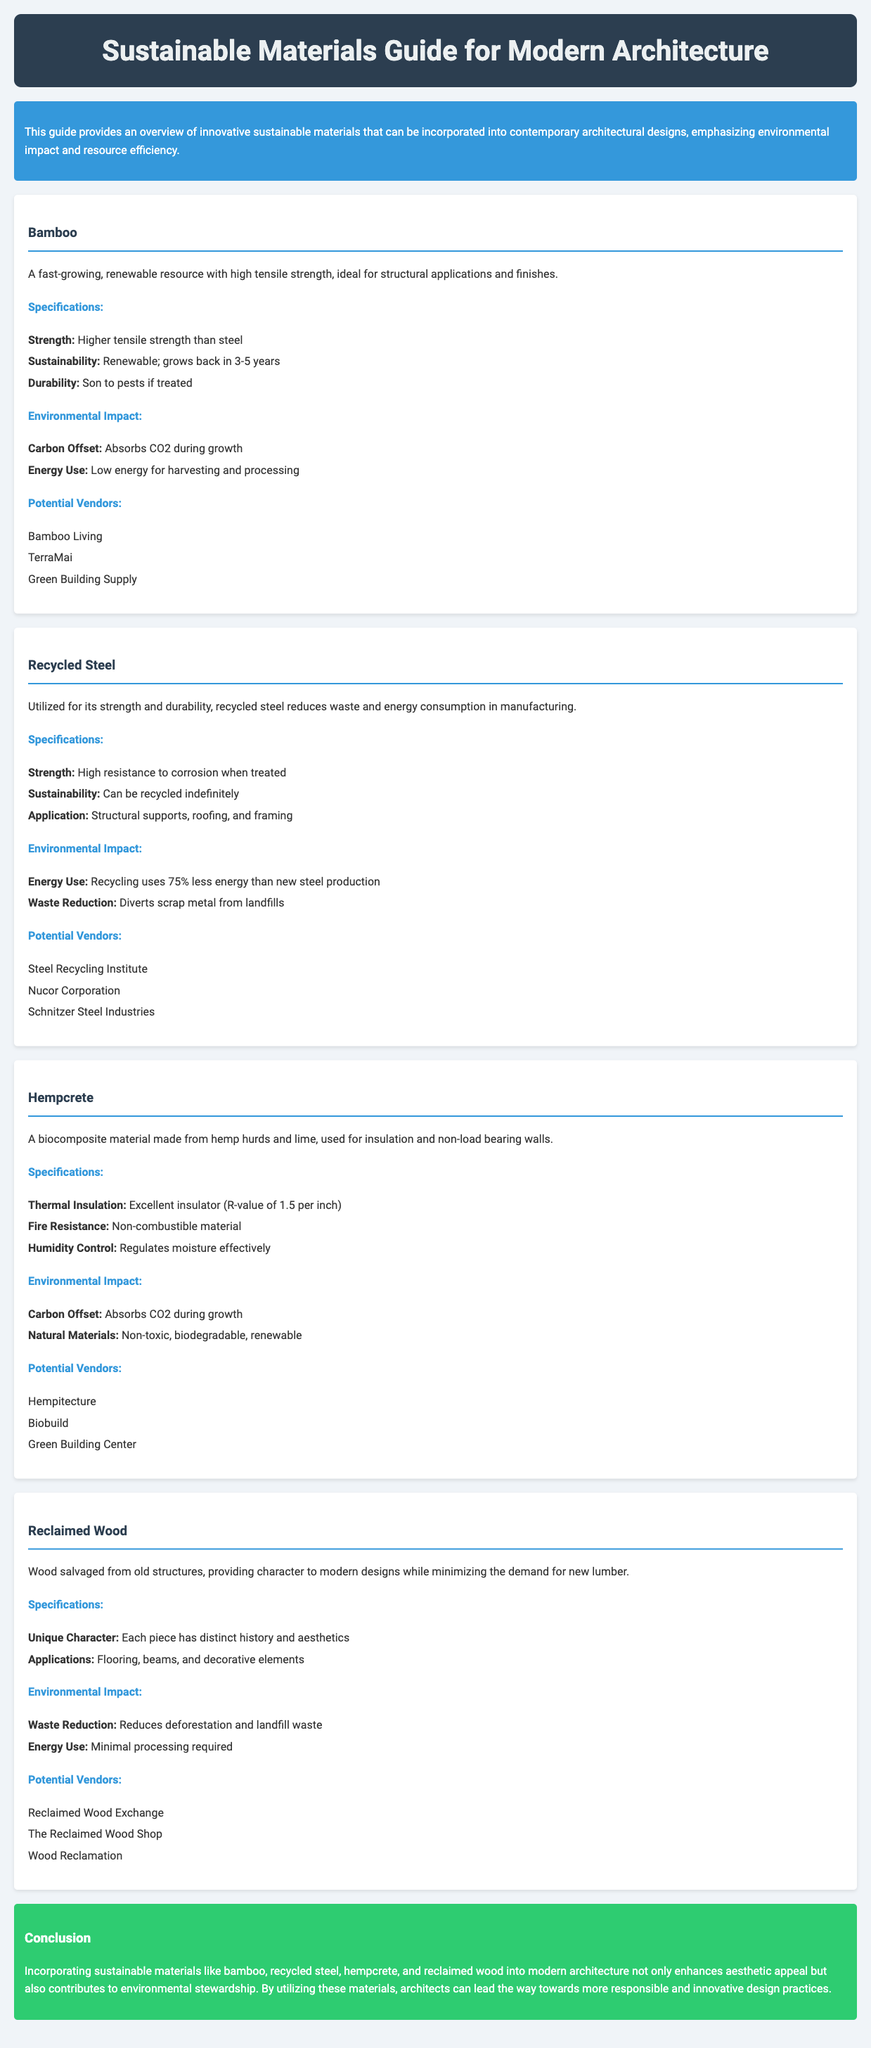what is a fast-growing renewable resource mentioned in the document? The document identifies bamboo as a fast-growing renewable resource with high tensile strength.
Answer: bamboo which material has higher tensile strength than steel? The document states that bamboo has higher tensile strength than steel.
Answer: bamboo what is the R-value of Hempcrete per inch? The document specifies that Hempcrete has an R-value of 1.5 per inch for thermal insulation.
Answer: 1.5 name one potential vendor for Reclaimed Wood. The document lists potential vendors for Reclaimed Wood, including Reclaimed Wood Exchange.
Answer: Reclaimed Wood Exchange what is a significant environmental benefit of recycled steel according to the manual? The document mentions that recycling steel uses 75% less energy than new steel production as a significant environmental benefit.
Answer: 75% less energy how does incorporating sustainable materials impact modern architecture? The document concludes that incorporating sustainable materials enhances aesthetic appeal and contributes to environmental stewardship.
Answer: enhances aesthetic appeal and contributes to environmental stewardship which material is indicated as non-combustible? The document states that Hempcrete is a non-combustible material.
Answer: Hempcrete what is one application of Reclaimed Wood mentioned in the document? The document states that Reclaimed Wood can be used for flooring as one of its applications.
Answer: flooring 